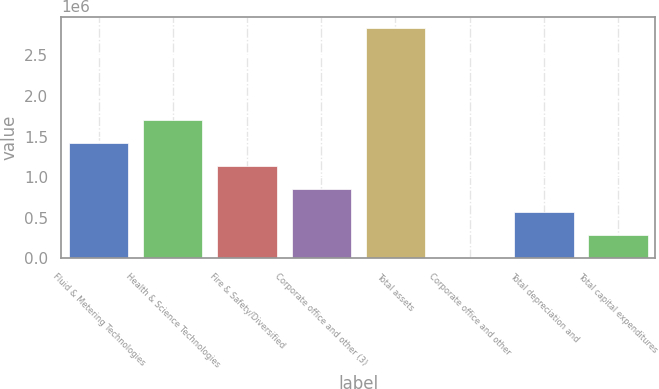Convert chart. <chart><loc_0><loc_0><loc_500><loc_500><bar_chart><fcel>Fluid & Metering Technologies<fcel>Health & Science Technologies<fcel>Fire & Safety/Diversified<fcel>Corporate office and other (3)<fcel>Total assets<fcel>Corporate office and other<fcel>Total depreciation and<fcel>Total capital expenditures<nl><fcel>1.41878e+06<fcel>1.70224e+06<fcel>1.13531e+06<fcel>851845<fcel>2.83611e+06<fcel>1447<fcel>568379<fcel>284913<nl></chart> 